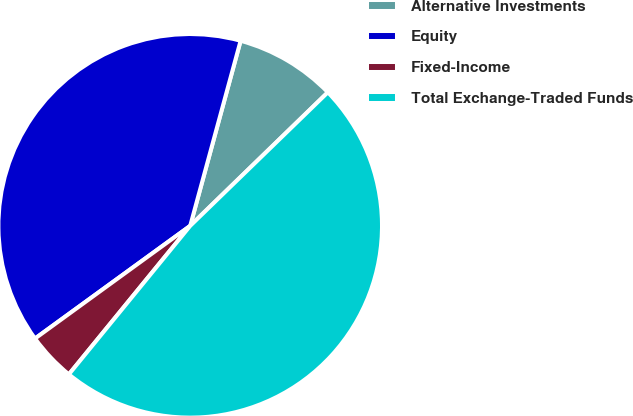Convert chart to OTSL. <chart><loc_0><loc_0><loc_500><loc_500><pie_chart><fcel>Alternative Investments<fcel>Equity<fcel>Fixed-Income<fcel>Total Exchange-Traded Funds<nl><fcel>8.51%<fcel>39.23%<fcel>4.1%<fcel>48.16%<nl></chart> 